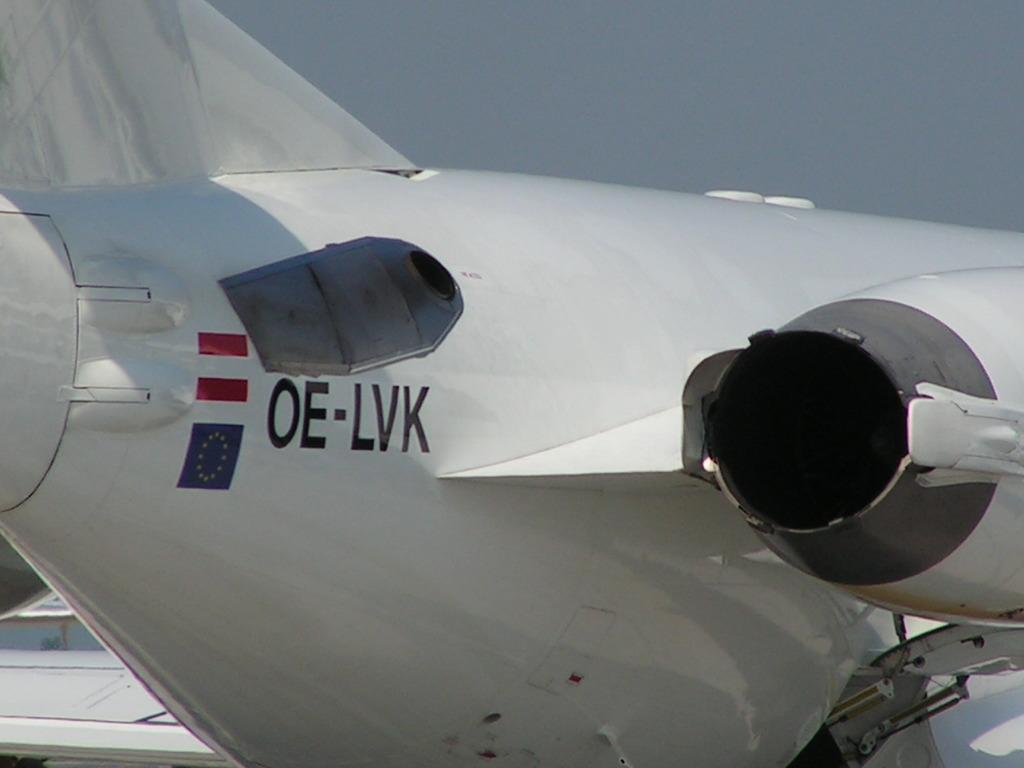<image>
Write a terse but informative summary of the picture. A white airplane with the letters OE-LVK written on it 